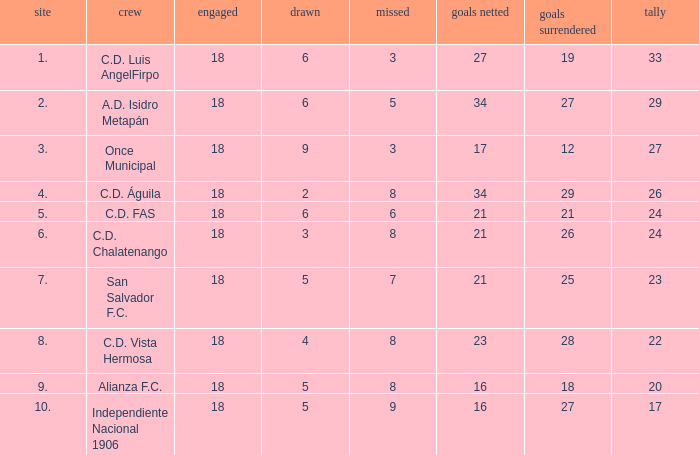What is the lowest amount of goals scored that has more than 19 goal conceded and played less than 18? None. 